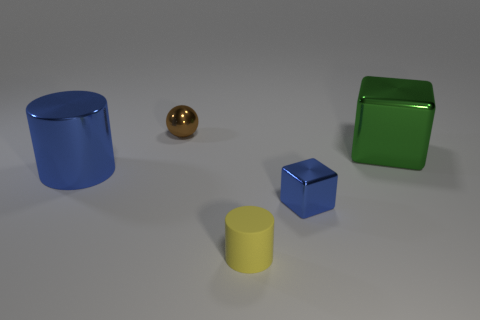There is a metallic object that is the same size as the brown metallic ball; what is its shape?
Your answer should be compact. Cube. Is the color of the large shiny thing that is to the right of the small metal sphere the same as the sphere?
Provide a short and direct response. No. How many things are either cylinders that are to the left of the small metal ball or tiny red shiny cubes?
Your answer should be very brief. 1. Are there more big blue cylinders on the left side of the large shiny cylinder than green metal things that are in front of the big green shiny cube?
Your response must be concise. No. Does the tiny blue object have the same material as the tiny yellow cylinder?
Your answer should be compact. No. What is the shape of the small object that is on the left side of the tiny blue cube and in front of the green object?
Provide a short and direct response. Cylinder. What shape is the big blue object that is the same material as the tiny blue block?
Your response must be concise. Cylinder. Is there a big green ball?
Ensure brevity in your answer.  No. Is there a brown object that is in front of the blue object in front of the blue cylinder?
Offer a very short reply. No. What is the material of the other thing that is the same shape as the tiny yellow object?
Provide a short and direct response. Metal. 